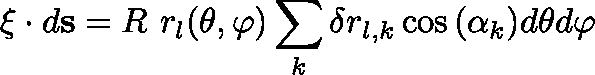Convert formula to latex. <formula><loc_0><loc_0><loc_500><loc_500>\xi \cdot d s = R \ r _ { l } ( \theta , \varphi ) \sum _ { k } \delta r _ { l , k } \cos { ( \alpha _ { k } ) } d \theta d \varphi</formula> 